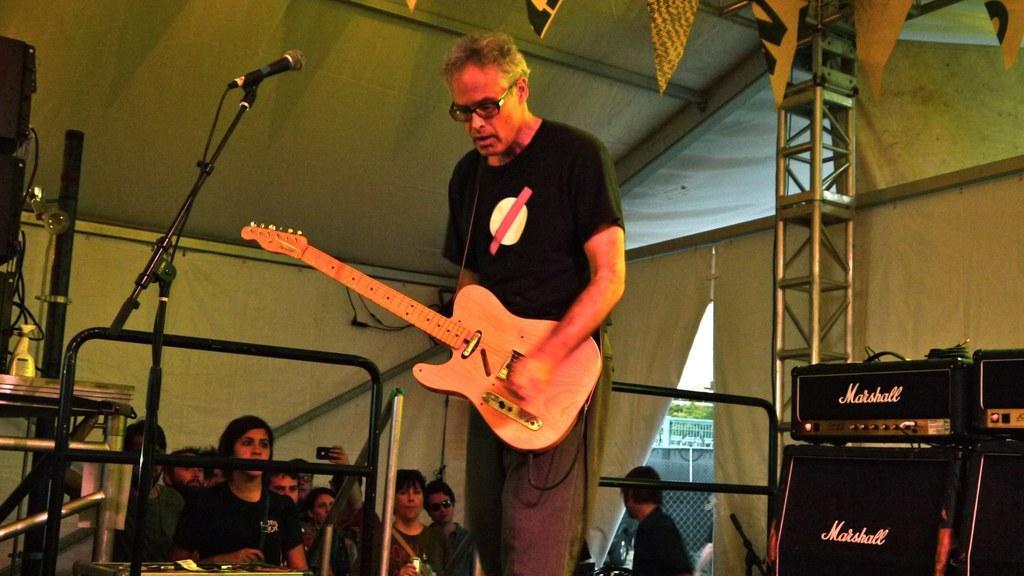Describe this image in one or two sentences. Here we can see that a person is standing on the floor and playing guitar, and in front here is the microphone and stand and at side there are group of people standing and here is the table and some objects on it. 